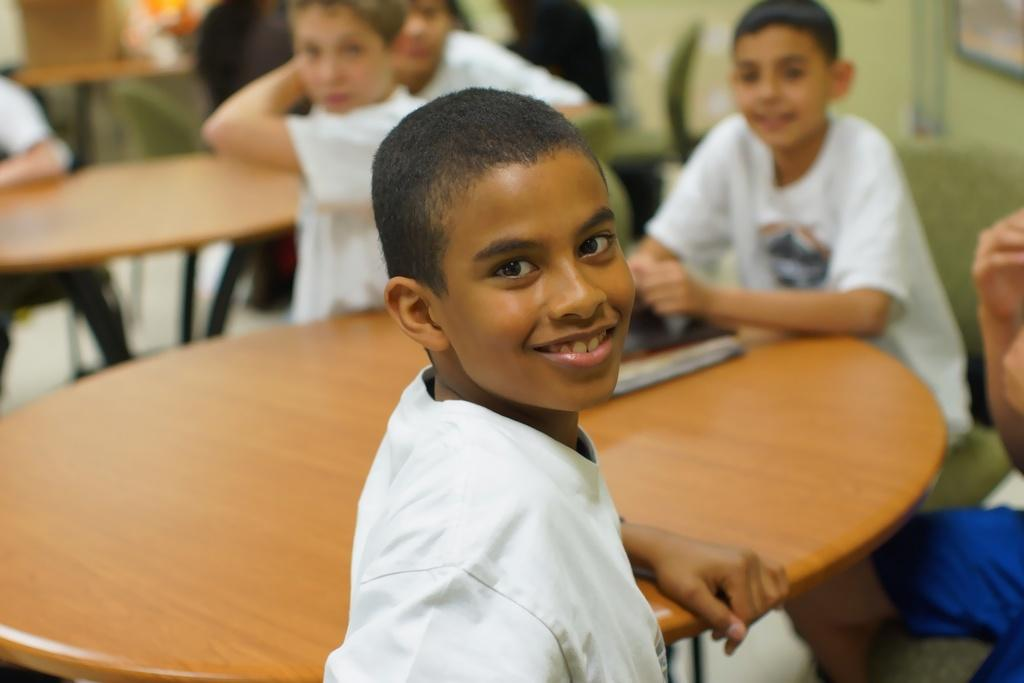Who is the main subject in the image? There is a boy in the image. What is the boy doing in the image? The boy is smiling. Where is the boy located in relation to the table? The boy is in front of a table. How many other boys can be seen in the image? There are multiple boys visible in the background. What else can be seen in the background? There is another table in the background. What is the purpose of the bath in the image? There is no bath present in the image. 